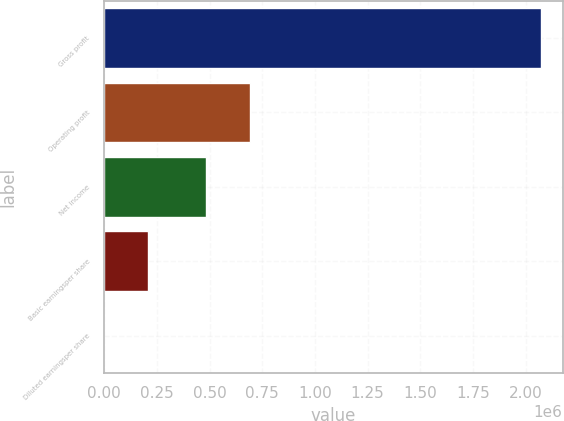<chart> <loc_0><loc_0><loc_500><loc_500><bar_chart><fcel>Gross profit<fcel>Operating profit<fcel>Net income<fcel>Basic earningsper share<fcel>Diluted earningsper share<nl><fcel>2.07169e+06<fcel>690410<fcel>483241<fcel>207171<fcel>1.84<nl></chart> 